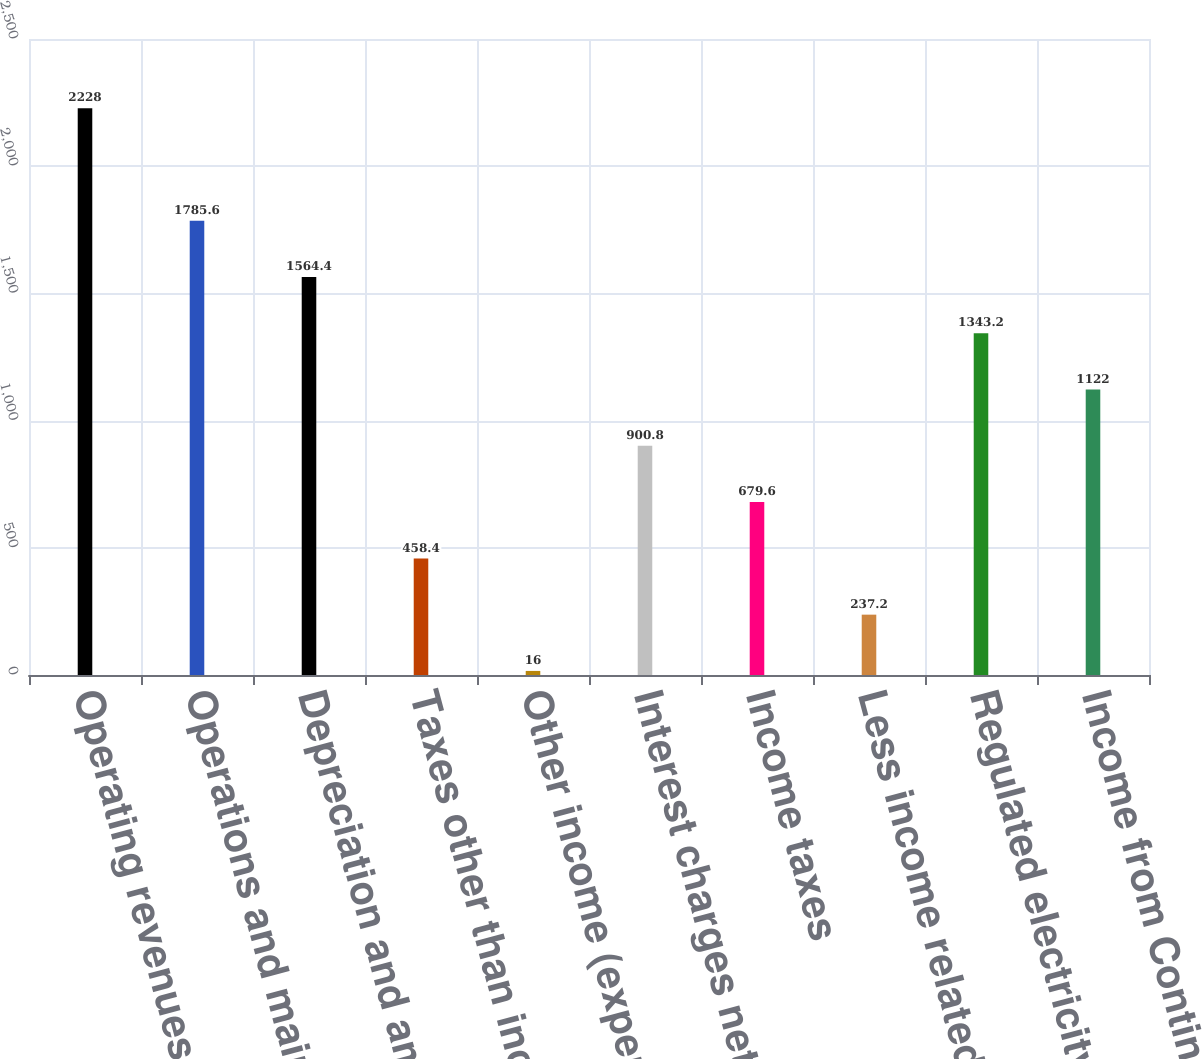Convert chart to OTSL. <chart><loc_0><loc_0><loc_500><loc_500><bar_chart><fcel>Operating revenues less fuel<fcel>Operations and maintenance (a)<fcel>Depreciation and amortization<fcel>Taxes other than income taxes<fcel>Other income (expenses) net<fcel>Interest charges net of<fcel>Income taxes<fcel>Less income related to<fcel>Regulated electricity segment<fcel>Income from Continuing<nl><fcel>2228<fcel>1785.6<fcel>1564.4<fcel>458.4<fcel>16<fcel>900.8<fcel>679.6<fcel>237.2<fcel>1343.2<fcel>1122<nl></chart> 